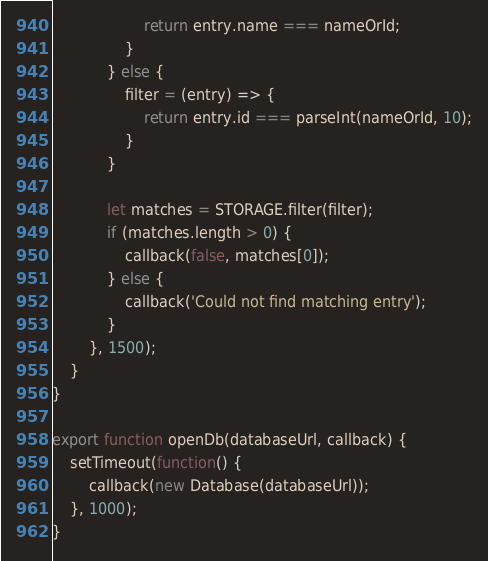Convert code to text. <code><loc_0><loc_0><loc_500><loc_500><_JavaScript_>                    return entry.name === nameOrId;
                }
            } else {
                filter = (entry) => {
                    return entry.id === parseInt(nameOrId, 10);
                }
            }

            let matches = STORAGE.filter(filter);
            if (matches.length > 0) {
                callback(false, matches[0]);
            } else {
                callback('Could not find matching entry');
            }
        }, 1500);
    }
}

export function openDb(databaseUrl, callback) {
    setTimeout(function() {
        callback(new Database(databaseUrl));
    }, 1000);
}</code> 